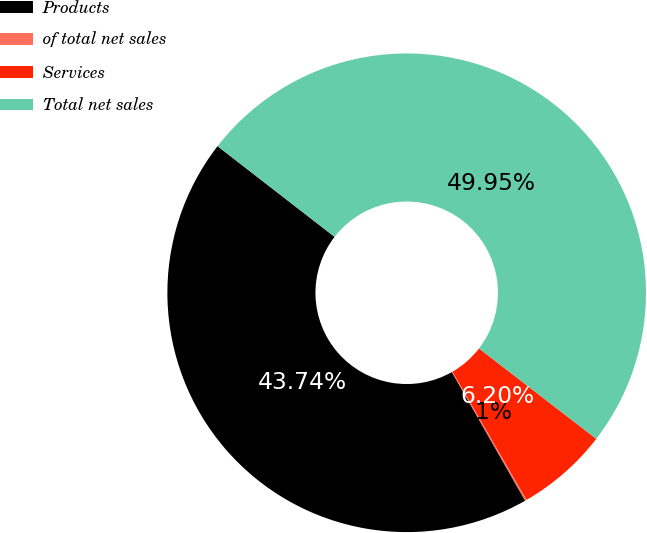<chart> <loc_0><loc_0><loc_500><loc_500><pie_chart><fcel>Products<fcel>of total net sales<fcel>Services<fcel>Total net sales<nl><fcel>43.74%<fcel>0.11%<fcel>6.2%<fcel>49.95%<nl></chart> 